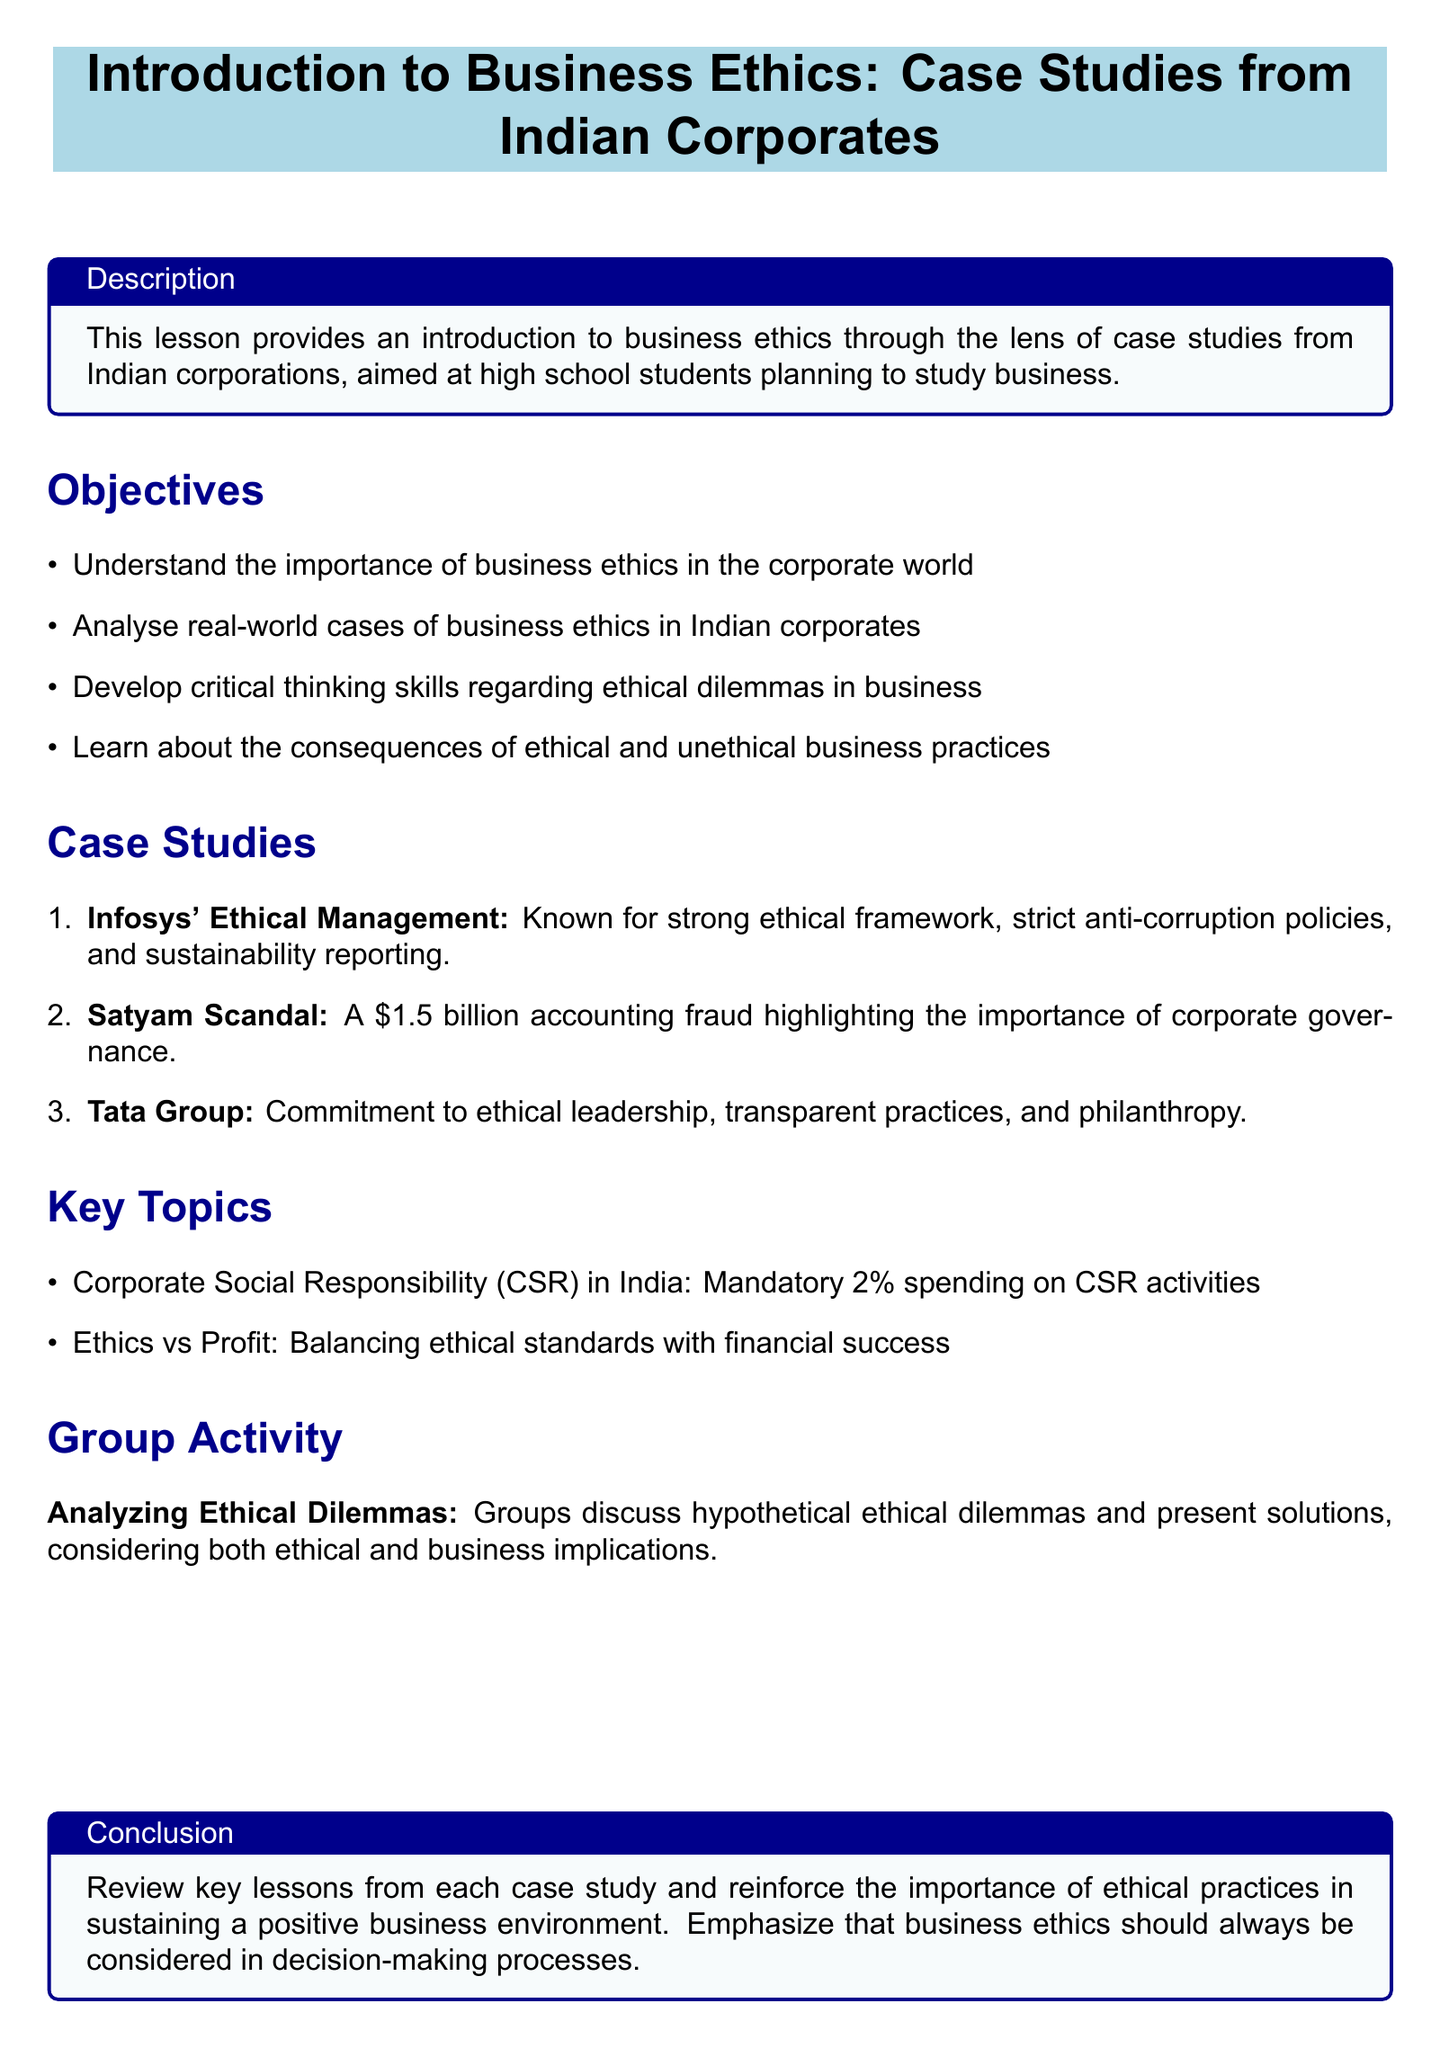What is the title of the lesson? The title is presented in a highlighted box at the beginning of the document.
Answer: Introduction to Business Ethics: Case Studies from Indian Corporates What is the first case study mentioned? The case studies are listed in a numbered format, with the first one highlighted for clarity.
Answer: Infosys' Ethical Management What is the financial amount involved in the Satyam scandal? The Satyam scandal is specified with a distinct monetary figure in the case study description.
Answer: 1.5 billion What is the mandatory CSR spending percentage in India? The document specifies a key topic regarding corporate social responsibility spending.
Answer: 2% What activity involves group discussions on ethical dilemmas? The group activity in the lesson plan outlines a specific task for students.
Answer: Analyzing Ethical Dilemmas What does the lesson emphasize at the end? The conclusion section summarizes the key lesson about business ethics.
Answer: Importance of ethical practices What is one key characteristic of the Tata Group from the case studies? The document provides specific attributes associated with Tata Group in the case studies section.
Answer: Ethical leadership What skills does the lesson plan aim to develop? The objectives outline the skills that students should gain from the lesson.
Answer: Critical thinking skills 